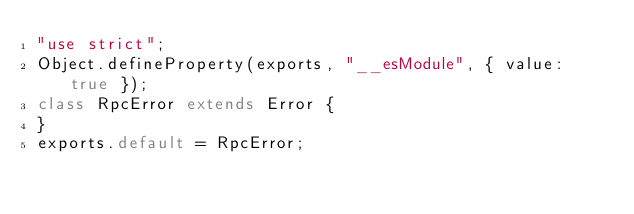<code> <loc_0><loc_0><loc_500><loc_500><_JavaScript_>"use strict";
Object.defineProperty(exports, "__esModule", { value: true });
class RpcError extends Error {
}
exports.default = RpcError;
</code> 